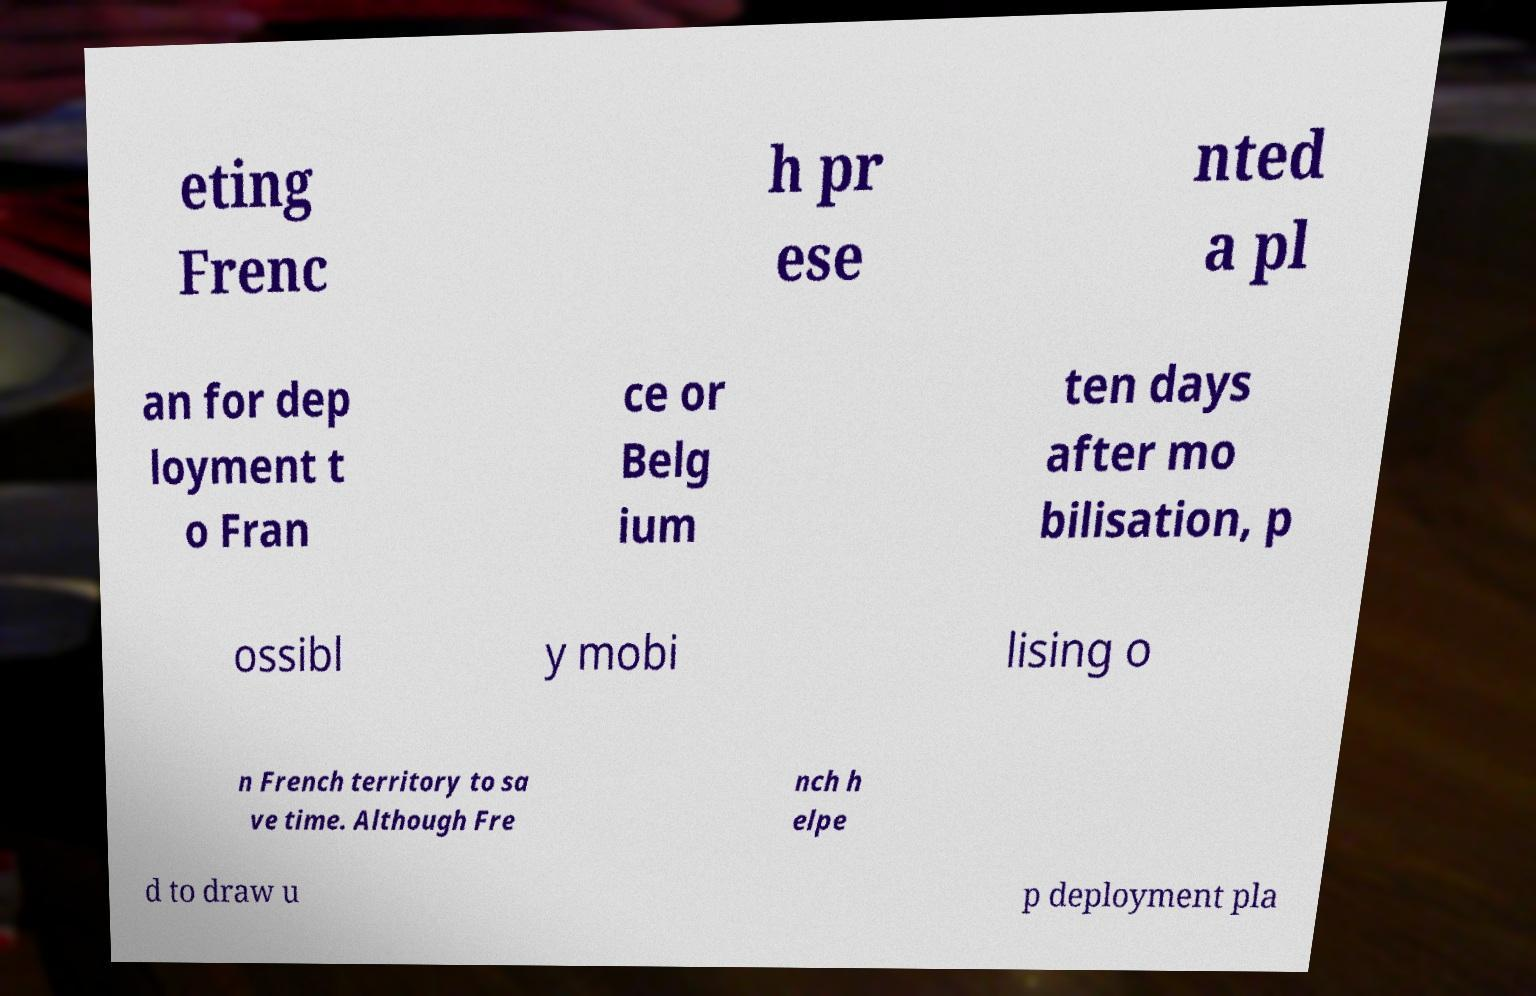Could you extract and type out the text from this image? eting Frenc h pr ese nted a pl an for dep loyment t o Fran ce or Belg ium ten days after mo bilisation, p ossibl y mobi lising o n French territory to sa ve time. Although Fre nch h elpe d to draw u p deployment pla 